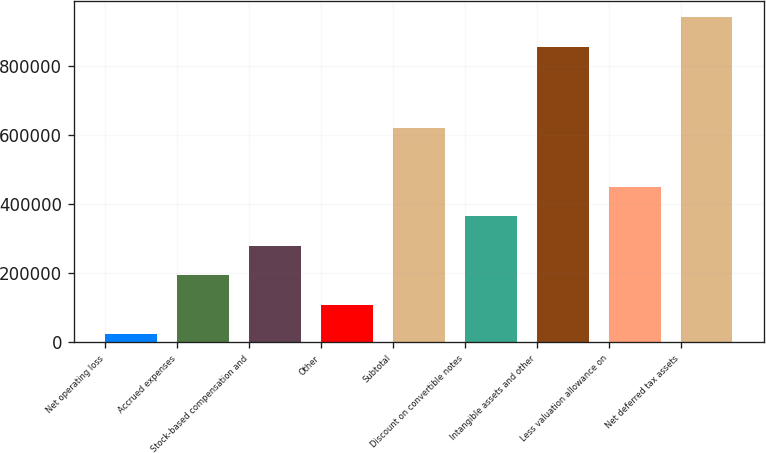<chart> <loc_0><loc_0><loc_500><loc_500><bar_chart><fcel>Net operating loss<fcel>Accrued expenses<fcel>Stock-based compensation and<fcel>Other<fcel>Subtotal<fcel>Discount on convertible notes<fcel>Intangible assets and other<fcel>Less valuation allowance on<fcel>Net deferred tax assets<nl><fcel>22353<fcel>193722<fcel>279407<fcel>108038<fcel>622146<fcel>365092<fcel>856807<fcel>450776<fcel>942492<nl></chart> 